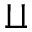Convert formula to latex. <formula><loc_0><loc_0><loc_500><loc_500>\amalg</formula> 